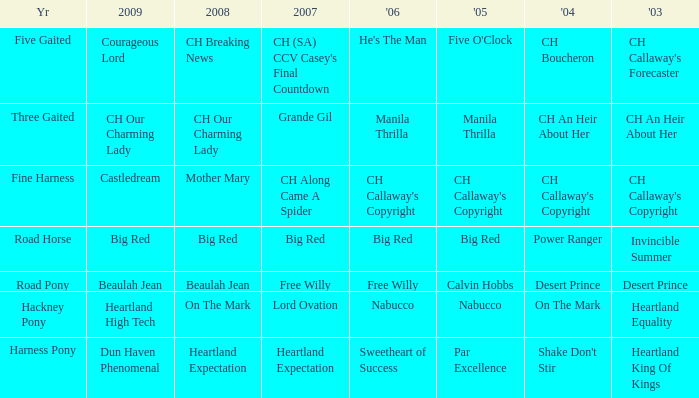What is the 2007 with ch callaway's copyright in 2003? CH Along Came A Spider. 